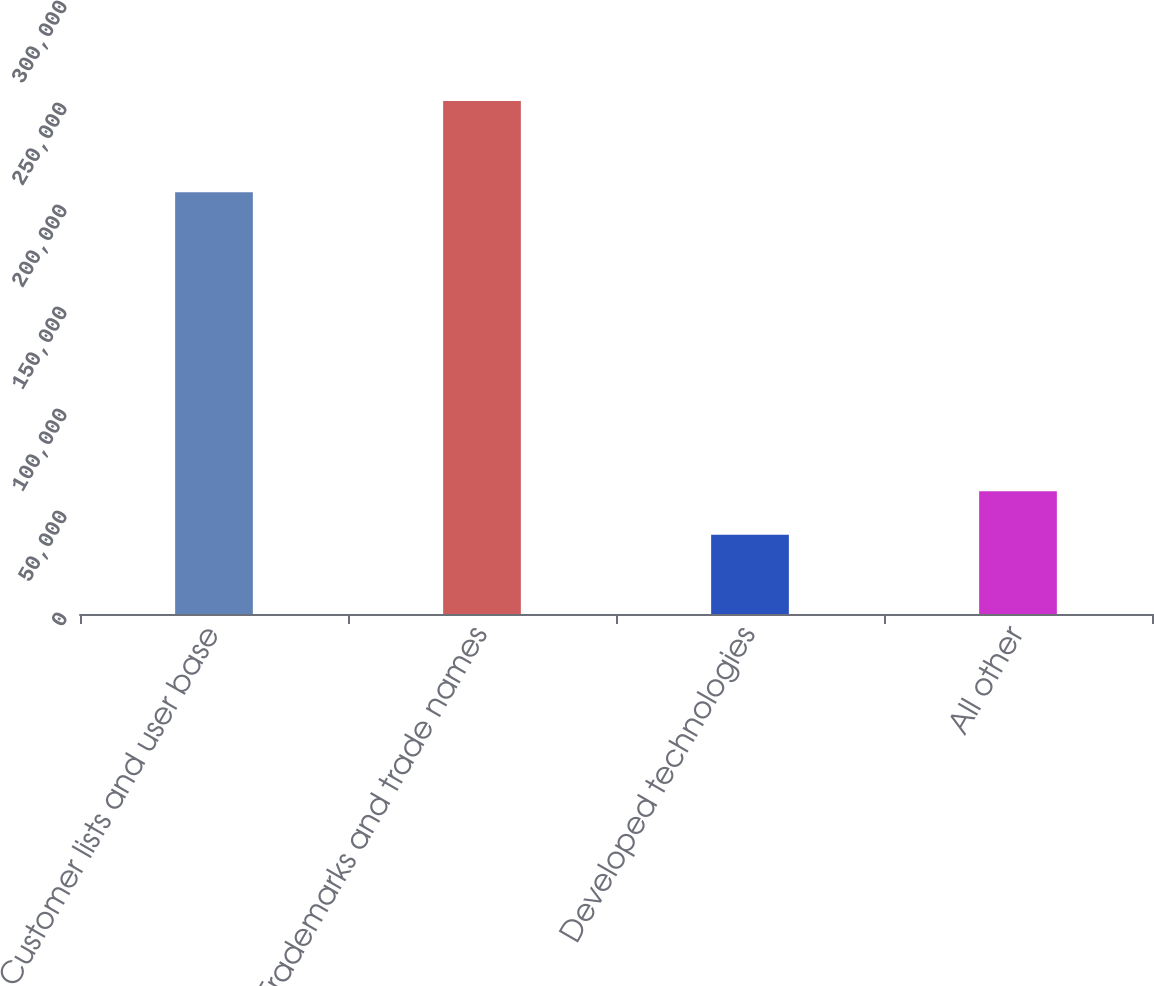<chart> <loc_0><loc_0><loc_500><loc_500><bar_chart><fcel>Customer lists and user base<fcel>Trademarks and trade names<fcel>Developed technologies<fcel>All other<nl><fcel>206680<fcel>251443<fcel>38891<fcel>60146.2<nl></chart> 